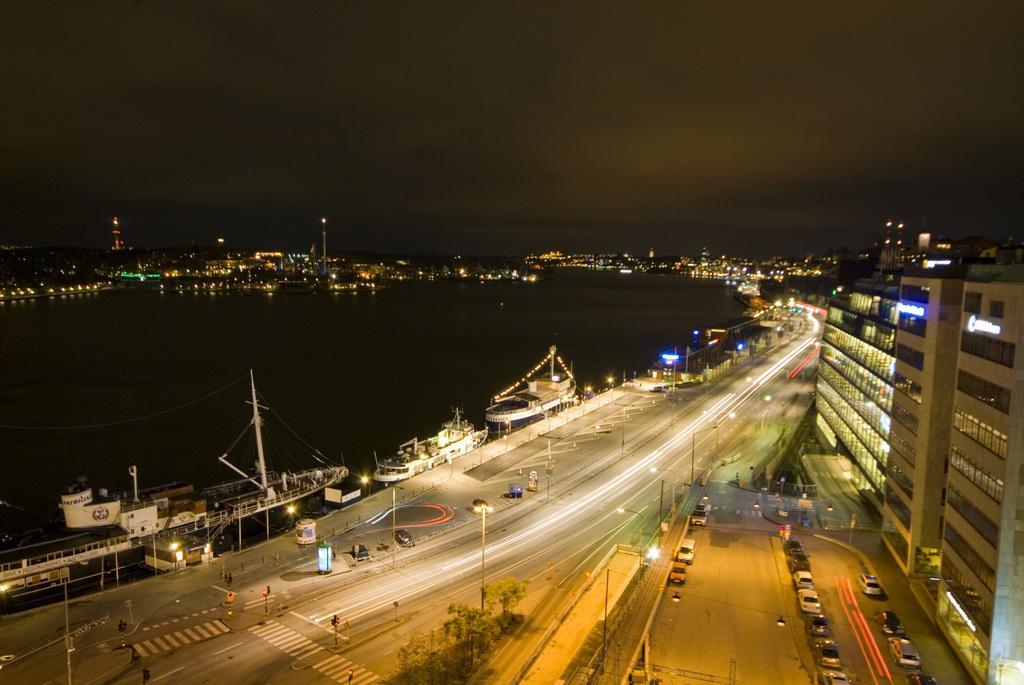Could you give a brief overview of what you see in this image? In this image we can see an outside view. To the right side of the image we can see building, a group of cars parked on the road. On the left side of the image we can see group of boats placed in water. In the background, we can see group of lights and sky. 